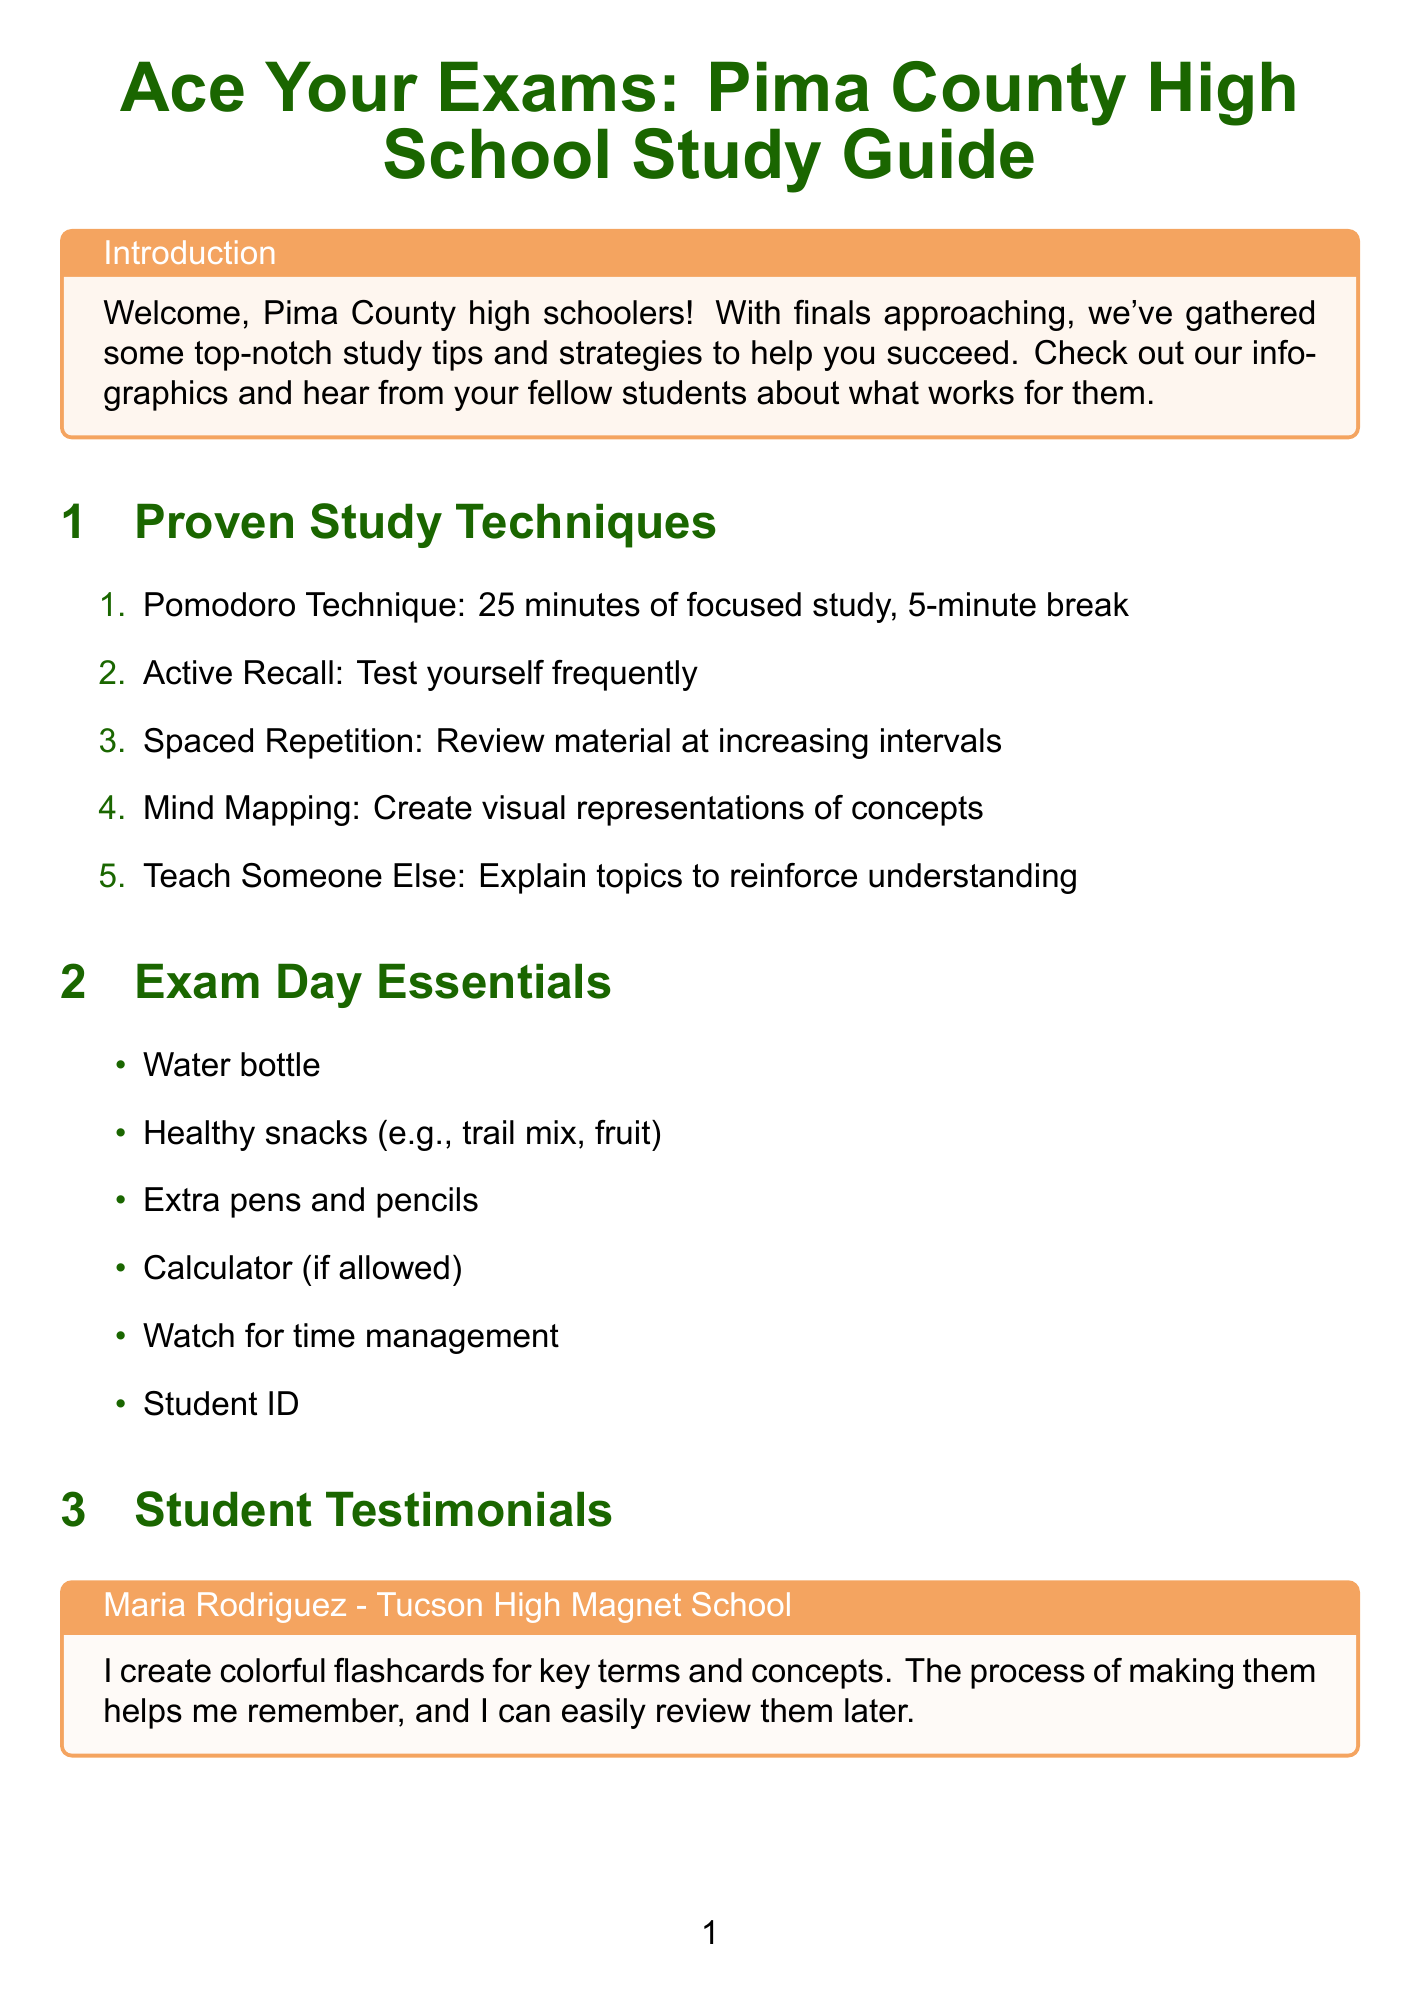What is the title of the newsletter? The title is listed at the top of the document, introducing the main theme of the content.
Answer: Ace Your Exams: Pima County High School Study Guide What technique involves 25 minutes of focused study? This technique is specified in the section discussing study techniques, focusing on time management.
Answer: Pomodoro Technique How many weeks before the exam should students start creating a study schedule? The timeline specifies when to begin various preparations for exams.
Answer: 2 weeks Which app does Jake Thompson use for studying? The testimonial section includes a mention of a specific app that Jake uses.
Answer: Quizlet What is one essential item to bring on exam day? The "Exam Day Essentials" section lists several necessary items for students during exams.
Answer: Water bottle What resource offers free online tutoring services? This refers to a local resource mentioned in the document that supports student learning.
Answer: Pima County Public Library What subject-specific tip suggests using Khan Academy? This information is found in the tips provided for a specific subject in the newsletter.
Answer: Math How do study groups help Alicia Begay? The testimonial includes insights on the benefits of studying in groups, emphasizing collaboration and review.
Answer: Makes studying more fun What is recommended for the night before the exam? The document outlines tasks to complete before the exam, highlighting important preparation strategies.
Answer: Get a good night's sleep (at least 8 hours) 